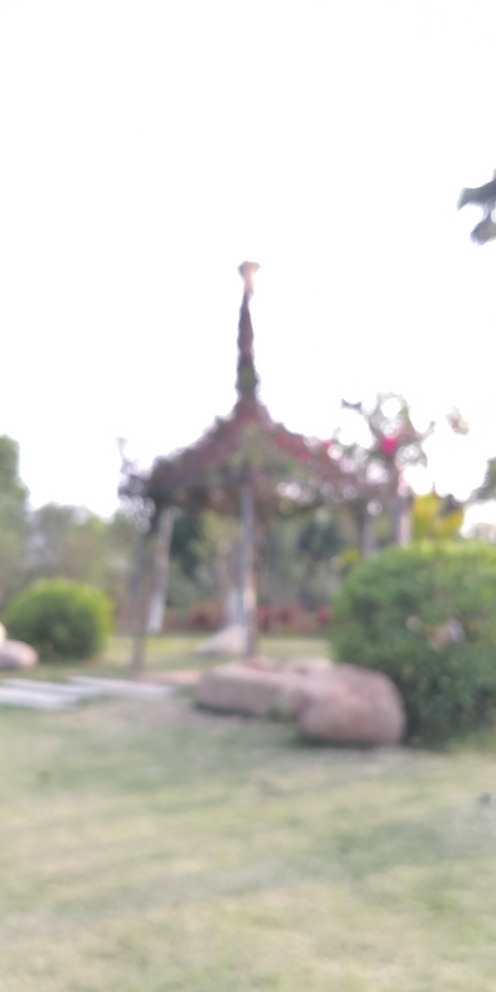What time of day does this scene depict? While the image is out of focus, there is sufficient light and no visible street lighting, which might suggest daytime. The softness of the light could indicate early morning or late afternoon hours. 